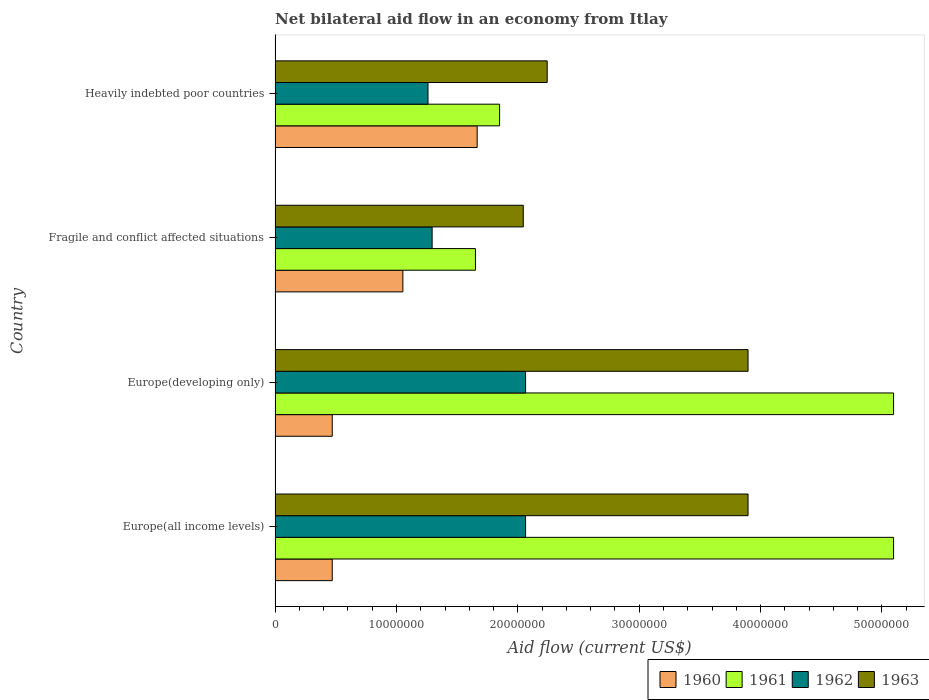How many different coloured bars are there?
Make the answer very short. 4. Are the number of bars per tick equal to the number of legend labels?
Your response must be concise. Yes. What is the label of the 3rd group of bars from the top?
Ensure brevity in your answer.  Europe(developing only). What is the net bilateral aid flow in 1961 in Europe(developing only)?
Provide a succinct answer. 5.10e+07. Across all countries, what is the maximum net bilateral aid flow in 1963?
Keep it short and to the point. 3.90e+07. Across all countries, what is the minimum net bilateral aid flow in 1962?
Ensure brevity in your answer.  1.26e+07. In which country was the net bilateral aid flow in 1963 maximum?
Offer a very short reply. Europe(all income levels). In which country was the net bilateral aid flow in 1963 minimum?
Your response must be concise. Fragile and conflict affected situations. What is the total net bilateral aid flow in 1961 in the graph?
Your response must be concise. 1.37e+08. What is the difference between the net bilateral aid flow in 1961 in Fragile and conflict affected situations and that in Heavily indebted poor countries?
Your answer should be compact. -1.99e+06. What is the difference between the net bilateral aid flow in 1962 in Heavily indebted poor countries and the net bilateral aid flow in 1961 in Europe(all income levels)?
Provide a short and direct response. -3.84e+07. What is the average net bilateral aid flow in 1961 per country?
Provide a short and direct response. 3.42e+07. What is the difference between the net bilateral aid flow in 1963 and net bilateral aid flow in 1960 in Heavily indebted poor countries?
Your answer should be very brief. 5.77e+06. What is the ratio of the net bilateral aid flow in 1961 in Europe(all income levels) to that in Heavily indebted poor countries?
Make the answer very short. 2.75. Is the net bilateral aid flow in 1961 in Europe(developing only) less than that in Fragile and conflict affected situations?
Offer a terse response. No. Is the difference between the net bilateral aid flow in 1963 in Europe(developing only) and Heavily indebted poor countries greater than the difference between the net bilateral aid flow in 1960 in Europe(developing only) and Heavily indebted poor countries?
Keep it short and to the point. Yes. What is the difference between the highest and the second highest net bilateral aid flow in 1960?
Give a very brief answer. 6.12e+06. What is the difference between the highest and the lowest net bilateral aid flow in 1962?
Offer a terse response. 8.04e+06. Is it the case that in every country, the sum of the net bilateral aid flow in 1961 and net bilateral aid flow in 1962 is greater than the sum of net bilateral aid flow in 1960 and net bilateral aid flow in 1963?
Your answer should be very brief. Yes. What does the 3rd bar from the bottom in Heavily indebted poor countries represents?
Your answer should be compact. 1962. Is it the case that in every country, the sum of the net bilateral aid flow in 1960 and net bilateral aid flow in 1961 is greater than the net bilateral aid flow in 1963?
Your answer should be very brief. Yes. How many bars are there?
Your response must be concise. 16. Are all the bars in the graph horizontal?
Offer a very short reply. Yes. How many countries are there in the graph?
Keep it short and to the point. 4. What is the difference between two consecutive major ticks on the X-axis?
Ensure brevity in your answer.  1.00e+07. Where does the legend appear in the graph?
Your response must be concise. Bottom right. What is the title of the graph?
Your answer should be very brief. Net bilateral aid flow in an economy from Itlay. Does "1960" appear as one of the legend labels in the graph?
Keep it short and to the point. Yes. What is the Aid flow (current US$) in 1960 in Europe(all income levels)?
Make the answer very short. 4.71e+06. What is the Aid flow (current US$) of 1961 in Europe(all income levels)?
Provide a succinct answer. 5.10e+07. What is the Aid flow (current US$) of 1962 in Europe(all income levels)?
Provide a succinct answer. 2.06e+07. What is the Aid flow (current US$) in 1963 in Europe(all income levels)?
Your response must be concise. 3.90e+07. What is the Aid flow (current US$) of 1960 in Europe(developing only)?
Your response must be concise. 4.71e+06. What is the Aid flow (current US$) of 1961 in Europe(developing only)?
Offer a terse response. 5.10e+07. What is the Aid flow (current US$) of 1962 in Europe(developing only)?
Your response must be concise. 2.06e+07. What is the Aid flow (current US$) in 1963 in Europe(developing only)?
Offer a terse response. 3.90e+07. What is the Aid flow (current US$) in 1960 in Fragile and conflict affected situations?
Your answer should be compact. 1.05e+07. What is the Aid flow (current US$) of 1961 in Fragile and conflict affected situations?
Offer a very short reply. 1.65e+07. What is the Aid flow (current US$) in 1962 in Fragile and conflict affected situations?
Your response must be concise. 1.29e+07. What is the Aid flow (current US$) of 1963 in Fragile and conflict affected situations?
Give a very brief answer. 2.04e+07. What is the Aid flow (current US$) in 1960 in Heavily indebted poor countries?
Offer a terse response. 1.66e+07. What is the Aid flow (current US$) in 1961 in Heavily indebted poor countries?
Your answer should be compact. 1.85e+07. What is the Aid flow (current US$) in 1962 in Heavily indebted poor countries?
Offer a terse response. 1.26e+07. What is the Aid flow (current US$) of 1963 in Heavily indebted poor countries?
Offer a terse response. 2.24e+07. Across all countries, what is the maximum Aid flow (current US$) of 1960?
Your answer should be very brief. 1.66e+07. Across all countries, what is the maximum Aid flow (current US$) in 1961?
Make the answer very short. 5.10e+07. Across all countries, what is the maximum Aid flow (current US$) of 1962?
Make the answer very short. 2.06e+07. Across all countries, what is the maximum Aid flow (current US$) in 1963?
Give a very brief answer. 3.90e+07. Across all countries, what is the minimum Aid flow (current US$) in 1960?
Provide a succinct answer. 4.71e+06. Across all countries, what is the minimum Aid flow (current US$) in 1961?
Offer a very short reply. 1.65e+07. Across all countries, what is the minimum Aid flow (current US$) of 1962?
Keep it short and to the point. 1.26e+07. Across all countries, what is the minimum Aid flow (current US$) of 1963?
Provide a succinct answer. 2.04e+07. What is the total Aid flow (current US$) of 1960 in the graph?
Make the answer very short. 3.66e+07. What is the total Aid flow (current US$) of 1961 in the graph?
Offer a terse response. 1.37e+08. What is the total Aid flow (current US$) of 1962 in the graph?
Offer a terse response. 6.68e+07. What is the total Aid flow (current US$) of 1963 in the graph?
Make the answer very short. 1.21e+08. What is the difference between the Aid flow (current US$) of 1961 in Europe(all income levels) and that in Europe(developing only)?
Ensure brevity in your answer.  0. What is the difference between the Aid flow (current US$) of 1960 in Europe(all income levels) and that in Fragile and conflict affected situations?
Your answer should be compact. -5.82e+06. What is the difference between the Aid flow (current US$) of 1961 in Europe(all income levels) and that in Fragile and conflict affected situations?
Ensure brevity in your answer.  3.44e+07. What is the difference between the Aid flow (current US$) in 1962 in Europe(all income levels) and that in Fragile and conflict affected situations?
Your answer should be compact. 7.70e+06. What is the difference between the Aid flow (current US$) of 1963 in Europe(all income levels) and that in Fragile and conflict affected situations?
Provide a succinct answer. 1.85e+07. What is the difference between the Aid flow (current US$) in 1960 in Europe(all income levels) and that in Heavily indebted poor countries?
Provide a short and direct response. -1.19e+07. What is the difference between the Aid flow (current US$) in 1961 in Europe(all income levels) and that in Heavily indebted poor countries?
Make the answer very short. 3.25e+07. What is the difference between the Aid flow (current US$) of 1962 in Europe(all income levels) and that in Heavily indebted poor countries?
Offer a terse response. 8.04e+06. What is the difference between the Aid flow (current US$) of 1963 in Europe(all income levels) and that in Heavily indebted poor countries?
Offer a very short reply. 1.66e+07. What is the difference between the Aid flow (current US$) of 1960 in Europe(developing only) and that in Fragile and conflict affected situations?
Ensure brevity in your answer.  -5.82e+06. What is the difference between the Aid flow (current US$) in 1961 in Europe(developing only) and that in Fragile and conflict affected situations?
Offer a very short reply. 3.44e+07. What is the difference between the Aid flow (current US$) in 1962 in Europe(developing only) and that in Fragile and conflict affected situations?
Your response must be concise. 7.70e+06. What is the difference between the Aid flow (current US$) in 1963 in Europe(developing only) and that in Fragile and conflict affected situations?
Keep it short and to the point. 1.85e+07. What is the difference between the Aid flow (current US$) in 1960 in Europe(developing only) and that in Heavily indebted poor countries?
Provide a succinct answer. -1.19e+07. What is the difference between the Aid flow (current US$) in 1961 in Europe(developing only) and that in Heavily indebted poor countries?
Make the answer very short. 3.25e+07. What is the difference between the Aid flow (current US$) of 1962 in Europe(developing only) and that in Heavily indebted poor countries?
Provide a short and direct response. 8.04e+06. What is the difference between the Aid flow (current US$) of 1963 in Europe(developing only) and that in Heavily indebted poor countries?
Keep it short and to the point. 1.66e+07. What is the difference between the Aid flow (current US$) in 1960 in Fragile and conflict affected situations and that in Heavily indebted poor countries?
Offer a terse response. -6.12e+06. What is the difference between the Aid flow (current US$) of 1961 in Fragile and conflict affected situations and that in Heavily indebted poor countries?
Keep it short and to the point. -1.99e+06. What is the difference between the Aid flow (current US$) of 1963 in Fragile and conflict affected situations and that in Heavily indebted poor countries?
Make the answer very short. -1.97e+06. What is the difference between the Aid flow (current US$) in 1960 in Europe(all income levels) and the Aid flow (current US$) in 1961 in Europe(developing only)?
Ensure brevity in your answer.  -4.62e+07. What is the difference between the Aid flow (current US$) in 1960 in Europe(all income levels) and the Aid flow (current US$) in 1962 in Europe(developing only)?
Ensure brevity in your answer.  -1.59e+07. What is the difference between the Aid flow (current US$) in 1960 in Europe(all income levels) and the Aid flow (current US$) in 1963 in Europe(developing only)?
Provide a short and direct response. -3.43e+07. What is the difference between the Aid flow (current US$) in 1961 in Europe(all income levels) and the Aid flow (current US$) in 1962 in Europe(developing only)?
Give a very brief answer. 3.03e+07. What is the difference between the Aid flow (current US$) in 1961 in Europe(all income levels) and the Aid flow (current US$) in 1963 in Europe(developing only)?
Offer a very short reply. 1.20e+07. What is the difference between the Aid flow (current US$) of 1962 in Europe(all income levels) and the Aid flow (current US$) of 1963 in Europe(developing only)?
Your response must be concise. -1.83e+07. What is the difference between the Aid flow (current US$) in 1960 in Europe(all income levels) and the Aid flow (current US$) in 1961 in Fragile and conflict affected situations?
Your answer should be very brief. -1.18e+07. What is the difference between the Aid flow (current US$) in 1960 in Europe(all income levels) and the Aid flow (current US$) in 1962 in Fragile and conflict affected situations?
Ensure brevity in your answer.  -8.23e+06. What is the difference between the Aid flow (current US$) of 1960 in Europe(all income levels) and the Aid flow (current US$) of 1963 in Fragile and conflict affected situations?
Offer a very short reply. -1.57e+07. What is the difference between the Aid flow (current US$) of 1961 in Europe(all income levels) and the Aid flow (current US$) of 1962 in Fragile and conflict affected situations?
Make the answer very short. 3.80e+07. What is the difference between the Aid flow (current US$) of 1961 in Europe(all income levels) and the Aid flow (current US$) of 1963 in Fragile and conflict affected situations?
Give a very brief answer. 3.05e+07. What is the difference between the Aid flow (current US$) of 1960 in Europe(all income levels) and the Aid flow (current US$) of 1961 in Heavily indebted poor countries?
Keep it short and to the point. -1.38e+07. What is the difference between the Aid flow (current US$) of 1960 in Europe(all income levels) and the Aid flow (current US$) of 1962 in Heavily indebted poor countries?
Offer a terse response. -7.89e+06. What is the difference between the Aid flow (current US$) in 1960 in Europe(all income levels) and the Aid flow (current US$) in 1963 in Heavily indebted poor countries?
Provide a short and direct response. -1.77e+07. What is the difference between the Aid flow (current US$) of 1961 in Europe(all income levels) and the Aid flow (current US$) of 1962 in Heavily indebted poor countries?
Your answer should be very brief. 3.84e+07. What is the difference between the Aid flow (current US$) in 1961 in Europe(all income levels) and the Aid flow (current US$) in 1963 in Heavily indebted poor countries?
Offer a very short reply. 2.85e+07. What is the difference between the Aid flow (current US$) of 1962 in Europe(all income levels) and the Aid flow (current US$) of 1963 in Heavily indebted poor countries?
Offer a very short reply. -1.78e+06. What is the difference between the Aid flow (current US$) in 1960 in Europe(developing only) and the Aid flow (current US$) in 1961 in Fragile and conflict affected situations?
Your answer should be compact. -1.18e+07. What is the difference between the Aid flow (current US$) of 1960 in Europe(developing only) and the Aid flow (current US$) of 1962 in Fragile and conflict affected situations?
Keep it short and to the point. -8.23e+06. What is the difference between the Aid flow (current US$) in 1960 in Europe(developing only) and the Aid flow (current US$) in 1963 in Fragile and conflict affected situations?
Ensure brevity in your answer.  -1.57e+07. What is the difference between the Aid flow (current US$) of 1961 in Europe(developing only) and the Aid flow (current US$) of 1962 in Fragile and conflict affected situations?
Make the answer very short. 3.80e+07. What is the difference between the Aid flow (current US$) in 1961 in Europe(developing only) and the Aid flow (current US$) in 1963 in Fragile and conflict affected situations?
Make the answer very short. 3.05e+07. What is the difference between the Aid flow (current US$) of 1962 in Europe(developing only) and the Aid flow (current US$) of 1963 in Fragile and conflict affected situations?
Ensure brevity in your answer.  1.90e+05. What is the difference between the Aid flow (current US$) in 1960 in Europe(developing only) and the Aid flow (current US$) in 1961 in Heavily indebted poor countries?
Ensure brevity in your answer.  -1.38e+07. What is the difference between the Aid flow (current US$) in 1960 in Europe(developing only) and the Aid flow (current US$) in 1962 in Heavily indebted poor countries?
Offer a very short reply. -7.89e+06. What is the difference between the Aid flow (current US$) in 1960 in Europe(developing only) and the Aid flow (current US$) in 1963 in Heavily indebted poor countries?
Your answer should be very brief. -1.77e+07. What is the difference between the Aid flow (current US$) of 1961 in Europe(developing only) and the Aid flow (current US$) of 1962 in Heavily indebted poor countries?
Keep it short and to the point. 3.84e+07. What is the difference between the Aid flow (current US$) of 1961 in Europe(developing only) and the Aid flow (current US$) of 1963 in Heavily indebted poor countries?
Your answer should be very brief. 2.85e+07. What is the difference between the Aid flow (current US$) in 1962 in Europe(developing only) and the Aid flow (current US$) in 1963 in Heavily indebted poor countries?
Ensure brevity in your answer.  -1.78e+06. What is the difference between the Aid flow (current US$) in 1960 in Fragile and conflict affected situations and the Aid flow (current US$) in 1961 in Heavily indebted poor countries?
Offer a terse response. -7.97e+06. What is the difference between the Aid flow (current US$) of 1960 in Fragile and conflict affected situations and the Aid flow (current US$) of 1962 in Heavily indebted poor countries?
Your answer should be very brief. -2.07e+06. What is the difference between the Aid flow (current US$) of 1960 in Fragile and conflict affected situations and the Aid flow (current US$) of 1963 in Heavily indebted poor countries?
Your answer should be very brief. -1.19e+07. What is the difference between the Aid flow (current US$) in 1961 in Fragile and conflict affected situations and the Aid flow (current US$) in 1962 in Heavily indebted poor countries?
Your response must be concise. 3.91e+06. What is the difference between the Aid flow (current US$) in 1961 in Fragile and conflict affected situations and the Aid flow (current US$) in 1963 in Heavily indebted poor countries?
Give a very brief answer. -5.91e+06. What is the difference between the Aid flow (current US$) of 1962 in Fragile and conflict affected situations and the Aid flow (current US$) of 1963 in Heavily indebted poor countries?
Offer a very short reply. -9.48e+06. What is the average Aid flow (current US$) of 1960 per country?
Provide a short and direct response. 9.15e+06. What is the average Aid flow (current US$) in 1961 per country?
Give a very brief answer. 3.42e+07. What is the average Aid flow (current US$) of 1962 per country?
Your answer should be compact. 1.67e+07. What is the average Aid flow (current US$) of 1963 per country?
Your response must be concise. 3.02e+07. What is the difference between the Aid flow (current US$) of 1960 and Aid flow (current US$) of 1961 in Europe(all income levels)?
Offer a very short reply. -4.62e+07. What is the difference between the Aid flow (current US$) of 1960 and Aid flow (current US$) of 1962 in Europe(all income levels)?
Provide a short and direct response. -1.59e+07. What is the difference between the Aid flow (current US$) in 1960 and Aid flow (current US$) in 1963 in Europe(all income levels)?
Make the answer very short. -3.43e+07. What is the difference between the Aid flow (current US$) of 1961 and Aid flow (current US$) of 1962 in Europe(all income levels)?
Your answer should be compact. 3.03e+07. What is the difference between the Aid flow (current US$) of 1961 and Aid flow (current US$) of 1963 in Europe(all income levels)?
Your response must be concise. 1.20e+07. What is the difference between the Aid flow (current US$) of 1962 and Aid flow (current US$) of 1963 in Europe(all income levels)?
Ensure brevity in your answer.  -1.83e+07. What is the difference between the Aid flow (current US$) of 1960 and Aid flow (current US$) of 1961 in Europe(developing only)?
Your answer should be very brief. -4.62e+07. What is the difference between the Aid flow (current US$) of 1960 and Aid flow (current US$) of 1962 in Europe(developing only)?
Your response must be concise. -1.59e+07. What is the difference between the Aid flow (current US$) of 1960 and Aid flow (current US$) of 1963 in Europe(developing only)?
Give a very brief answer. -3.43e+07. What is the difference between the Aid flow (current US$) in 1961 and Aid flow (current US$) in 1962 in Europe(developing only)?
Make the answer very short. 3.03e+07. What is the difference between the Aid flow (current US$) of 1961 and Aid flow (current US$) of 1963 in Europe(developing only)?
Keep it short and to the point. 1.20e+07. What is the difference between the Aid flow (current US$) in 1962 and Aid flow (current US$) in 1963 in Europe(developing only)?
Give a very brief answer. -1.83e+07. What is the difference between the Aid flow (current US$) of 1960 and Aid flow (current US$) of 1961 in Fragile and conflict affected situations?
Offer a terse response. -5.98e+06. What is the difference between the Aid flow (current US$) in 1960 and Aid flow (current US$) in 1962 in Fragile and conflict affected situations?
Provide a succinct answer. -2.41e+06. What is the difference between the Aid flow (current US$) in 1960 and Aid flow (current US$) in 1963 in Fragile and conflict affected situations?
Give a very brief answer. -9.92e+06. What is the difference between the Aid flow (current US$) in 1961 and Aid flow (current US$) in 1962 in Fragile and conflict affected situations?
Give a very brief answer. 3.57e+06. What is the difference between the Aid flow (current US$) in 1961 and Aid flow (current US$) in 1963 in Fragile and conflict affected situations?
Your answer should be very brief. -3.94e+06. What is the difference between the Aid flow (current US$) in 1962 and Aid flow (current US$) in 1963 in Fragile and conflict affected situations?
Your answer should be compact. -7.51e+06. What is the difference between the Aid flow (current US$) in 1960 and Aid flow (current US$) in 1961 in Heavily indebted poor countries?
Offer a very short reply. -1.85e+06. What is the difference between the Aid flow (current US$) in 1960 and Aid flow (current US$) in 1962 in Heavily indebted poor countries?
Your response must be concise. 4.05e+06. What is the difference between the Aid flow (current US$) in 1960 and Aid flow (current US$) in 1963 in Heavily indebted poor countries?
Offer a terse response. -5.77e+06. What is the difference between the Aid flow (current US$) of 1961 and Aid flow (current US$) of 1962 in Heavily indebted poor countries?
Provide a succinct answer. 5.90e+06. What is the difference between the Aid flow (current US$) in 1961 and Aid flow (current US$) in 1963 in Heavily indebted poor countries?
Offer a very short reply. -3.92e+06. What is the difference between the Aid flow (current US$) of 1962 and Aid flow (current US$) of 1963 in Heavily indebted poor countries?
Make the answer very short. -9.82e+06. What is the ratio of the Aid flow (current US$) of 1960 in Europe(all income levels) to that in Europe(developing only)?
Your answer should be compact. 1. What is the ratio of the Aid flow (current US$) of 1961 in Europe(all income levels) to that in Europe(developing only)?
Your answer should be compact. 1. What is the ratio of the Aid flow (current US$) of 1962 in Europe(all income levels) to that in Europe(developing only)?
Provide a succinct answer. 1. What is the ratio of the Aid flow (current US$) in 1960 in Europe(all income levels) to that in Fragile and conflict affected situations?
Your answer should be very brief. 0.45. What is the ratio of the Aid flow (current US$) of 1961 in Europe(all income levels) to that in Fragile and conflict affected situations?
Offer a terse response. 3.09. What is the ratio of the Aid flow (current US$) in 1962 in Europe(all income levels) to that in Fragile and conflict affected situations?
Provide a short and direct response. 1.6. What is the ratio of the Aid flow (current US$) in 1963 in Europe(all income levels) to that in Fragile and conflict affected situations?
Give a very brief answer. 1.91. What is the ratio of the Aid flow (current US$) in 1960 in Europe(all income levels) to that in Heavily indebted poor countries?
Provide a succinct answer. 0.28. What is the ratio of the Aid flow (current US$) of 1961 in Europe(all income levels) to that in Heavily indebted poor countries?
Your answer should be very brief. 2.75. What is the ratio of the Aid flow (current US$) of 1962 in Europe(all income levels) to that in Heavily indebted poor countries?
Ensure brevity in your answer.  1.64. What is the ratio of the Aid flow (current US$) of 1963 in Europe(all income levels) to that in Heavily indebted poor countries?
Provide a short and direct response. 1.74. What is the ratio of the Aid flow (current US$) of 1960 in Europe(developing only) to that in Fragile and conflict affected situations?
Make the answer very short. 0.45. What is the ratio of the Aid flow (current US$) of 1961 in Europe(developing only) to that in Fragile and conflict affected situations?
Your response must be concise. 3.09. What is the ratio of the Aid flow (current US$) of 1962 in Europe(developing only) to that in Fragile and conflict affected situations?
Your answer should be compact. 1.6. What is the ratio of the Aid flow (current US$) in 1963 in Europe(developing only) to that in Fragile and conflict affected situations?
Provide a succinct answer. 1.91. What is the ratio of the Aid flow (current US$) in 1960 in Europe(developing only) to that in Heavily indebted poor countries?
Provide a short and direct response. 0.28. What is the ratio of the Aid flow (current US$) in 1961 in Europe(developing only) to that in Heavily indebted poor countries?
Make the answer very short. 2.75. What is the ratio of the Aid flow (current US$) of 1962 in Europe(developing only) to that in Heavily indebted poor countries?
Offer a terse response. 1.64. What is the ratio of the Aid flow (current US$) of 1963 in Europe(developing only) to that in Heavily indebted poor countries?
Provide a short and direct response. 1.74. What is the ratio of the Aid flow (current US$) in 1960 in Fragile and conflict affected situations to that in Heavily indebted poor countries?
Make the answer very short. 0.63. What is the ratio of the Aid flow (current US$) of 1961 in Fragile and conflict affected situations to that in Heavily indebted poor countries?
Offer a terse response. 0.89. What is the ratio of the Aid flow (current US$) of 1962 in Fragile and conflict affected situations to that in Heavily indebted poor countries?
Your answer should be compact. 1.03. What is the ratio of the Aid flow (current US$) of 1963 in Fragile and conflict affected situations to that in Heavily indebted poor countries?
Your answer should be compact. 0.91. What is the difference between the highest and the second highest Aid flow (current US$) of 1960?
Give a very brief answer. 6.12e+06. What is the difference between the highest and the second highest Aid flow (current US$) in 1961?
Give a very brief answer. 0. What is the difference between the highest and the second highest Aid flow (current US$) in 1963?
Provide a succinct answer. 0. What is the difference between the highest and the lowest Aid flow (current US$) of 1960?
Your answer should be compact. 1.19e+07. What is the difference between the highest and the lowest Aid flow (current US$) of 1961?
Provide a short and direct response. 3.44e+07. What is the difference between the highest and the lowest Aid flow (current US$) in 1962?
Offer a terse response. 8.04e+06. What is the difference between the highest and the lowest Aid flow (current US$) in 1963?
Provide a succinct answer. 1.85e+07. 